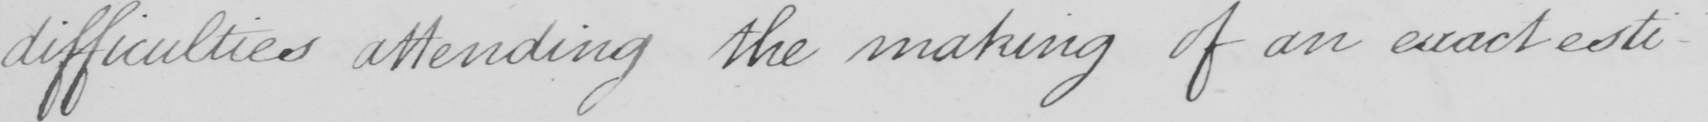Please provide the text content of this handwritten line. difficulties attending the making of an exact esti- 